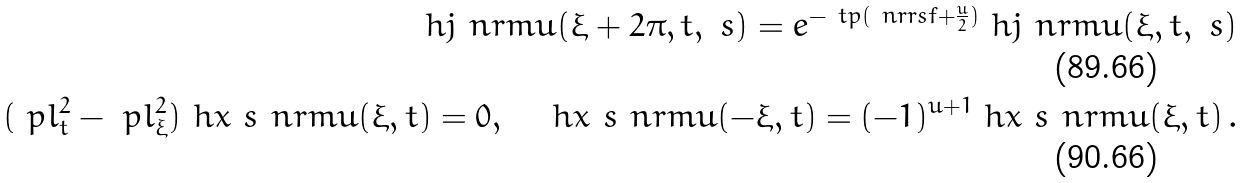Convert formula to latex. <formula><loc_0><loc_0><loc_500><loc_500>\ h j _ { \ } n r m u ( \xi + 2 \pi , t , \ s ) = e ^ { - \ t p ( \ n r r s f + \frac { u } { 2 } ) } \ h j _ { \ } n r m u ( \xi , t , \ s ) \\ ( \ p l _ { t } ^ { 2 } - \ p l _ { \xi } ^ { 2 } ) \ h x ^ { \ } s _ { \ } n r m u ( \xi , t ) = 0 , \quad \ h x ^ { \ } s _ { \ } n r m u ( - \xi , t ) = ( - 1 ) ^ { u + 1 } \ h x ^ { \ } s _ { \ } n r m u ( \xi , t ) \, .</formula> 